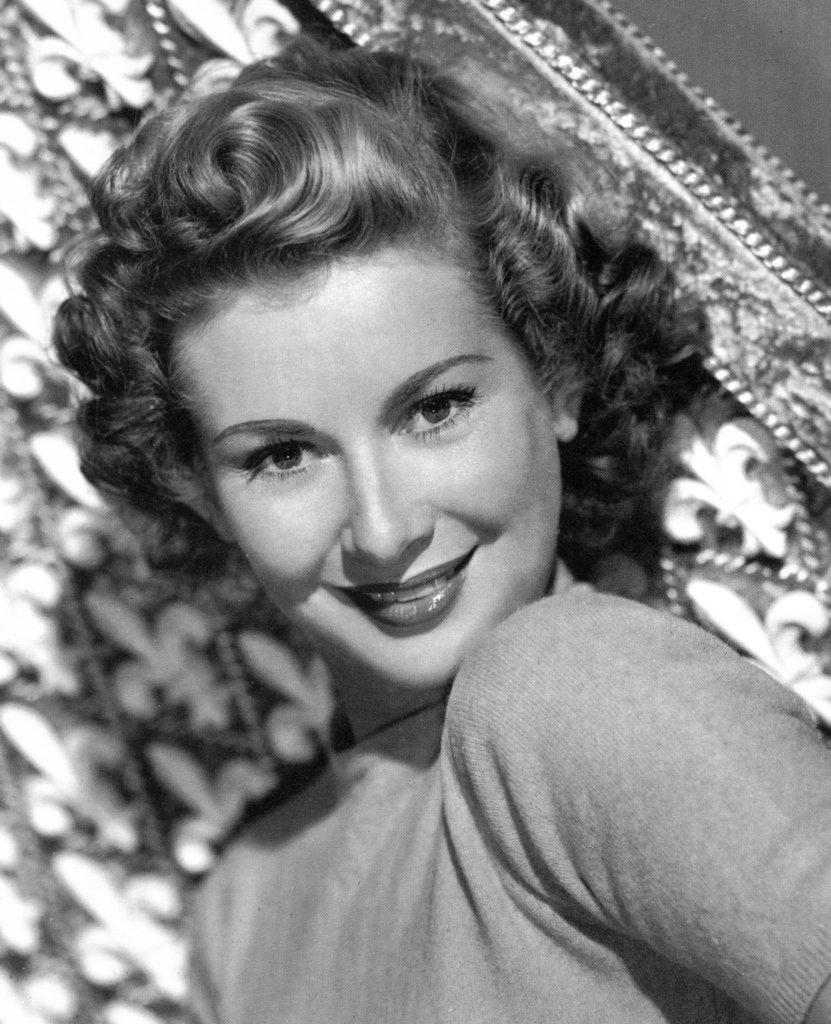What is the main subject of the image? There is a picture of a woman in the image. Where is the picture of the woman located in the image? The picture of the woman is in the middle of the image. What can be seen in the background of the image? There is a cloth in the background of the image. How many boys are present in the image? There are no boys present in the image; it features a picture of a woman. Is there a baby visible in the image? There is no baby visible in the image; it features a picture of a woman. 